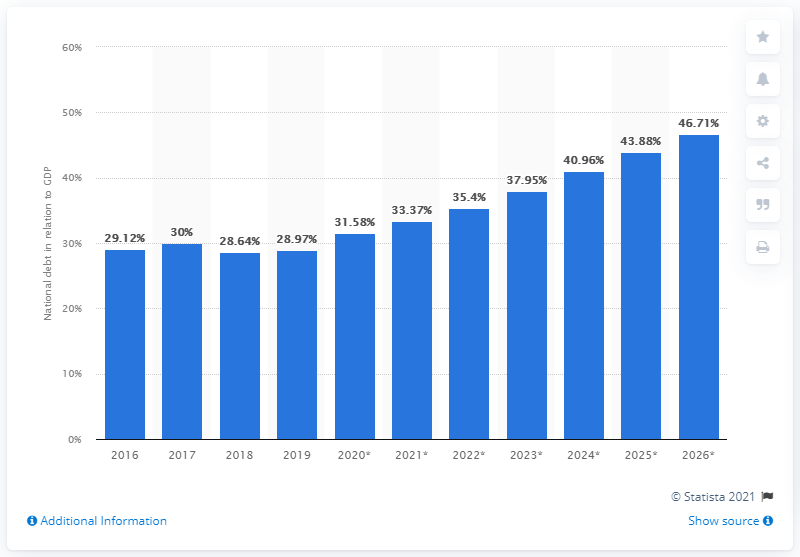Draw attention to some important aspects in this diagram. In 2019, the national debt of Cambodia was 28.97. 